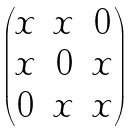Convert formula to latex. <formula><loc_0><loc_0><loc_500><loc_500>\begin{pmatrix} x & x & 0 \\ x & 0 & x \\ 0 & x & x \\ \end{pmatrix}</formula> 